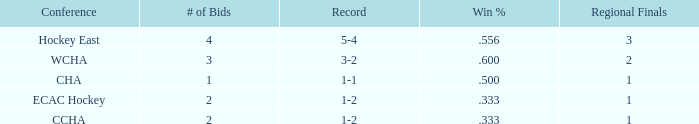What is the average Regional Finals score when the record is 3-2 and there are more than 3 bids? None. 